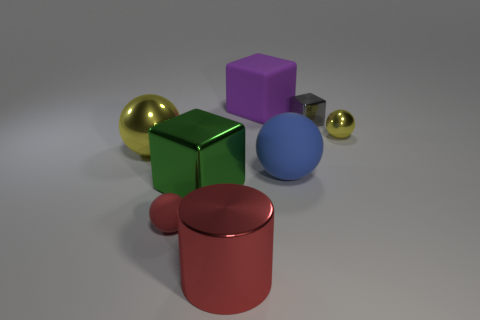Add 2 tiny brown metallic blocks. How many objects exist? 10 Subtract all cubes. How many objects are left? 5 Add 4 small rubber things. How many small rubber things are left? 5 Add 7 purple rubber balls. How many purple rubber balls exist? 7 Subtract 0 brown cylinders. How many objects are left? 8 Subtract all tiny purple things. Subtract all large spheres. How many objects are left? 6 